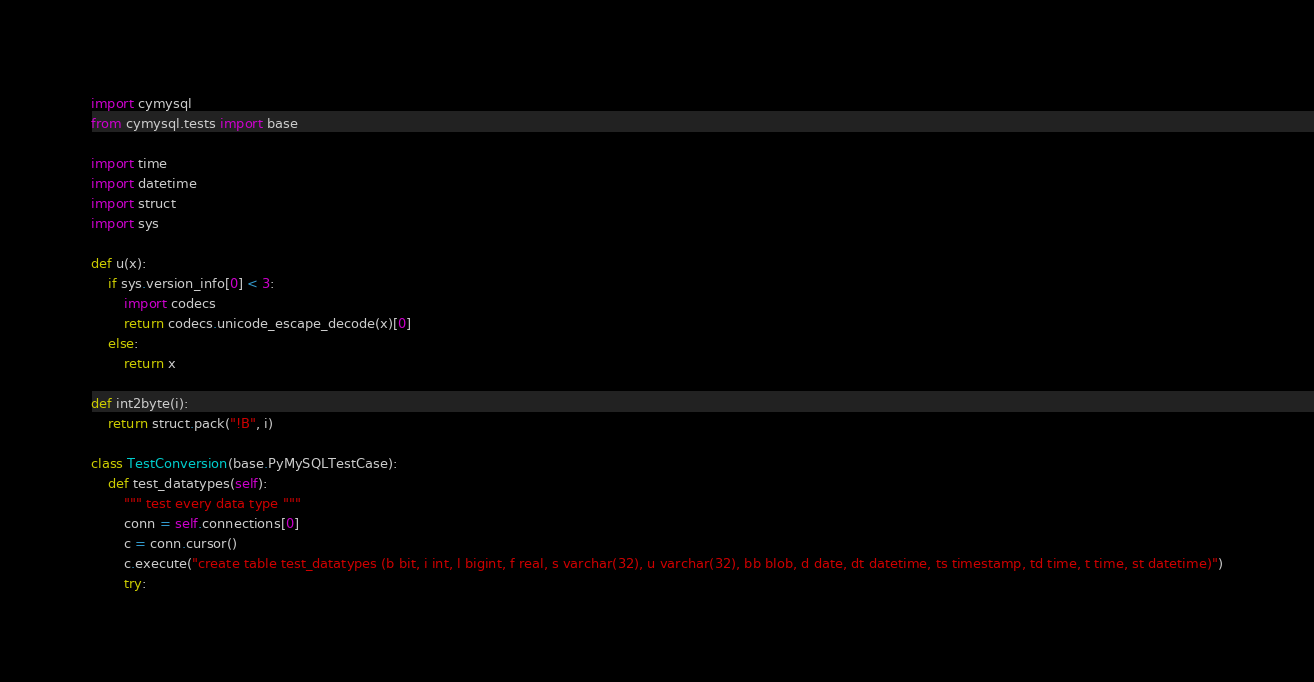<code> <loc_0><loc_0><loc_500><loc_500><_Python_>import cymysql
from cymysql.tests import base

import time
import datetime
import struct
import sys

def u(x):
    if sys.version_info[0] < 3:
        import codecs
        return codecs.unicode_escape_decode(x)[0]
    else:
        return x

def int2byte(i):
    return struct.pack("!B", i)

class TestConversion(base.PyMySQLTestCase):
    def test_datatypes(self):
        """ test every data type """
        conn = self.connections[0]
        c = conn.cursor()
        c.execute("create table test_datatypes (b bit, i int, l bigint, f real, s varchar(32), u varchar(32), bb blob, d date, dt datetime, ts timestamp, td time, t time, st datetime)")
        try:</code> 